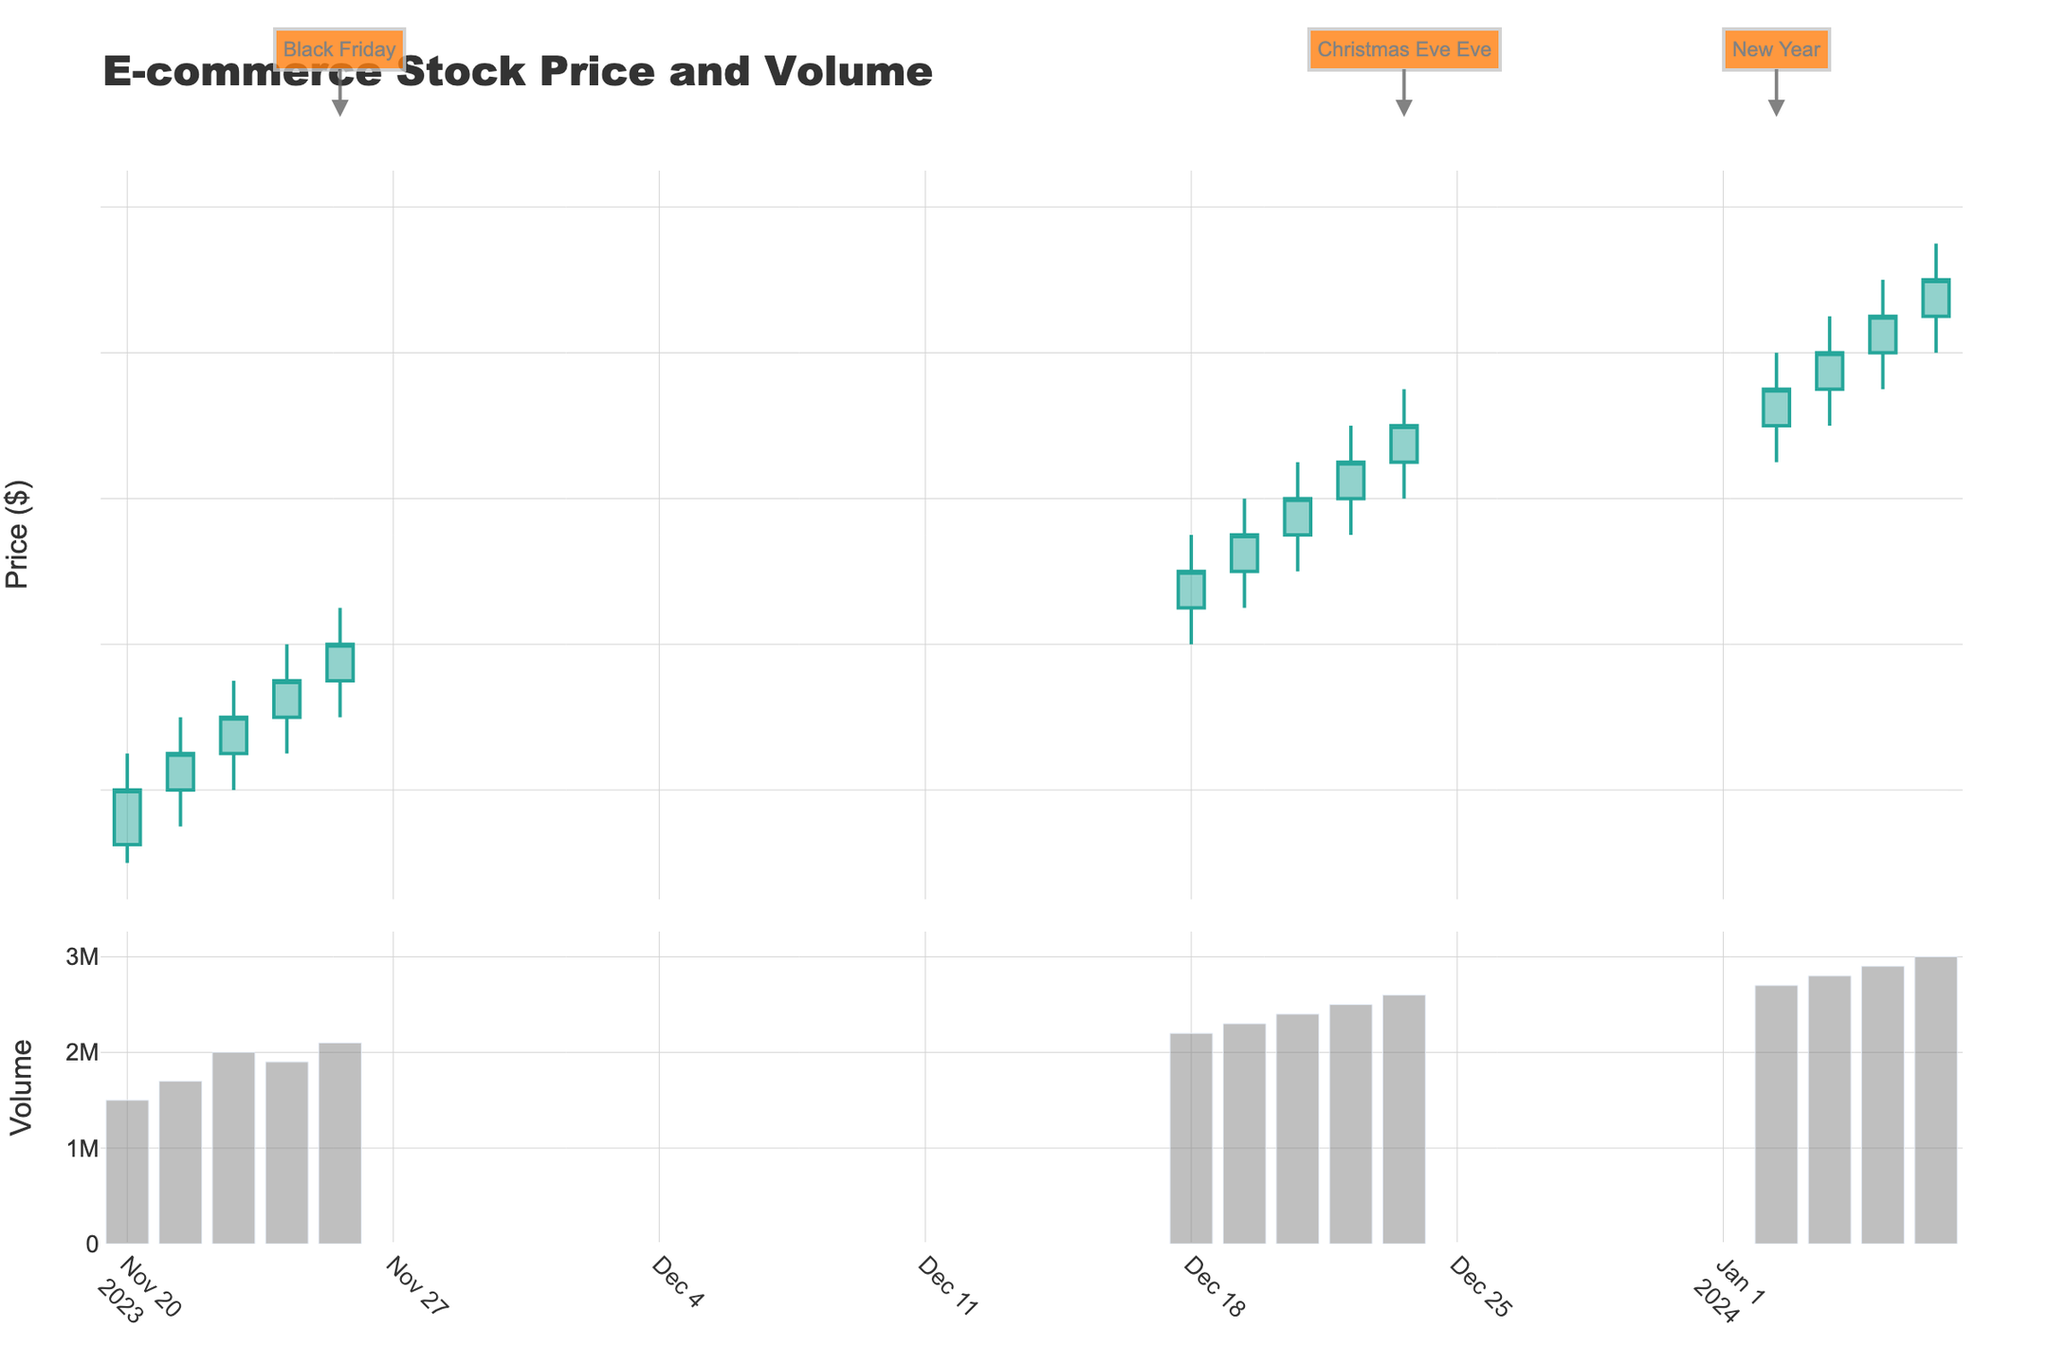what is the title of the figure? The title of the figure is displayed at the top, typically in larger, bold font.
Answer: E-commerce Stock Price and Volume How many holidays are marked in the figure? Holidays are marked with annotations, which can be seen as highlights on specific dates. Counting these annotations will give the number of holidays marked.
Answer: 3 What is the color of the increasing candlestick lines? The increasing candlestick lines, which represent days where the closing price is higher than the opening price, are colored distinctly to differentiate them from the decreasing lines. The color is typically noted in the legend or the visual appearance.
Answer: Greenish (#26a69a) What is the lowest closing price in the dataset? To find the lowest closing price, observe the "Close" values of the candlesticks and identify the minimum value.
Answer: $320.00 Which date has the highest trading volume? The highest trading volume can be found by comparing the height of the bar chart sections in the volume subplot. The tallest bar indicates the highest volume.
Answer: 2024-01-06 What is the trend in stock prices around Black Friday? Analyze the colors and directions of the candlesticks around the date marked as Black Friday on the chart to understand whether prices are generally increasing or decreasing.
Answer: Increasing How does the volume compare between Christmas Eve Eve and New Year? Compare the height of the bars in the volume subplot on the dates marked as Christmas Eve Eve and New Year to find out which date had higher trading volume.
Answer: New Year What is the average closing price in December 2023? To find the average closing price, sum the closing prices of all trading days in December 2023 and divide by the number of trading days in that month. The specific dates are December 18 to December 22, the closing prices are: $350, $355, $360, $365, and $370. Sum these values: $350 + $355 + $360 + $365 + $370 = $1,800, then divide by 5 (the number of trading days).
Answer: $360.00 How does the December 2023 average closing price compare to January 2024? First, calculate the average closing price for both months separately, then compare the two averages. For January 2024, the closing prices are $375, $380, $385, $390, and $395 over five trading days. Sum these values: $375 + $380 + $385 + $390 + $395 = $1,925, then divide by 5 to get the average: $1,925 / 5 = $385. December's average was already calculated as $360. Now, compare the two: $385 (January) is higher than $360 (December).
Answer: January's average is higher What can you infer about the stock price movement after New Year? Examine the candlestick colors and directions immediately after the New Year holiday marked in the figure to infer whether the stock price generally increased or decreased.
Answer: Increased 